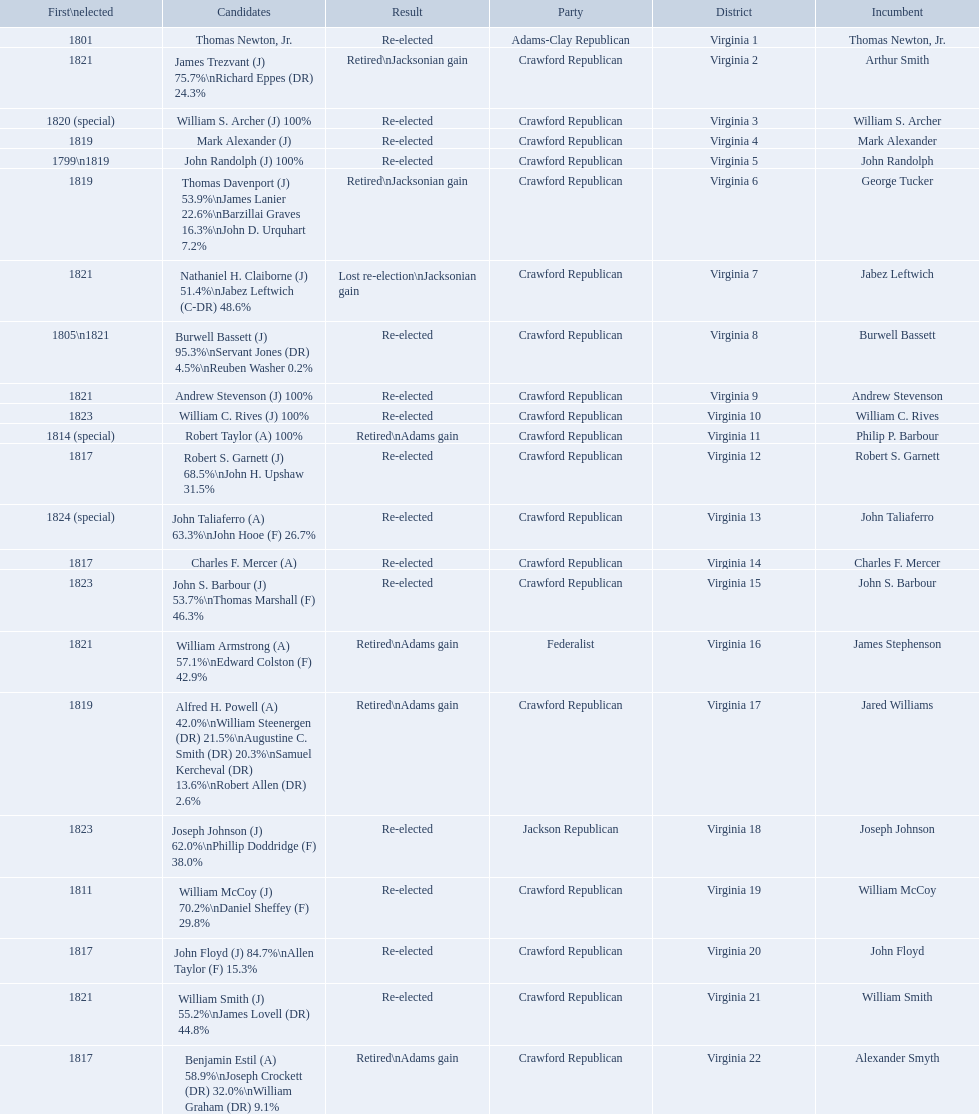Which incumbents belonged to the crawford republican party? Arthur Smith, William S. Archer, Mark Alexander, John Randolph, George Tucker, Jabez Leftwich, Burwell Bassett, Andrew Stevenson, William C. Rives, Philip P. Barbour, Robert S. Garnett, John Taliaferro, Charles F. Mercer, John S. Barbour, Jared Williams, William McCoy, John Floyd, William Smith, Alexander Smyth. Which of these incumbents were first elected in 1821? Arthur Smith, Jabez Leftwich, Andrew Stevenson, William Smith. Which of these incumbents have a last name of smith? Arthur Smith, William Smith. Which of these two were not re-elected? Arthur Smith. 